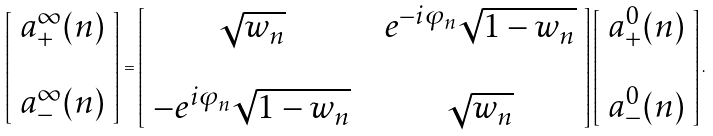<formula> <loc_0><loc_0><loc_500><loc_500>\left [ \begin{array} { l } a _ { + } ^ { \infty } ( n ) \\ \\ a _ { - } ^ { \infty } ( n ) \end{array} \right ] = \left [ \begin{array} { c c c } \sqrt { w _ { n } } & & e ^ { - i \varphi _ { n } } \sqrt { 1 - w _ { n } } \\ & & \\ - e ^ { i \varphi _ { n } } \sqrt { 1 - w _ { n } } & & \sqrt { w _ { n } } \end{array} \right ] \left [ \begin{array} { l } a _ { + } ^ { 0 } ( n ) \\ \\ a _ { - } ^ { 0 } ( n ) \end{array} \right ] .</formula> 